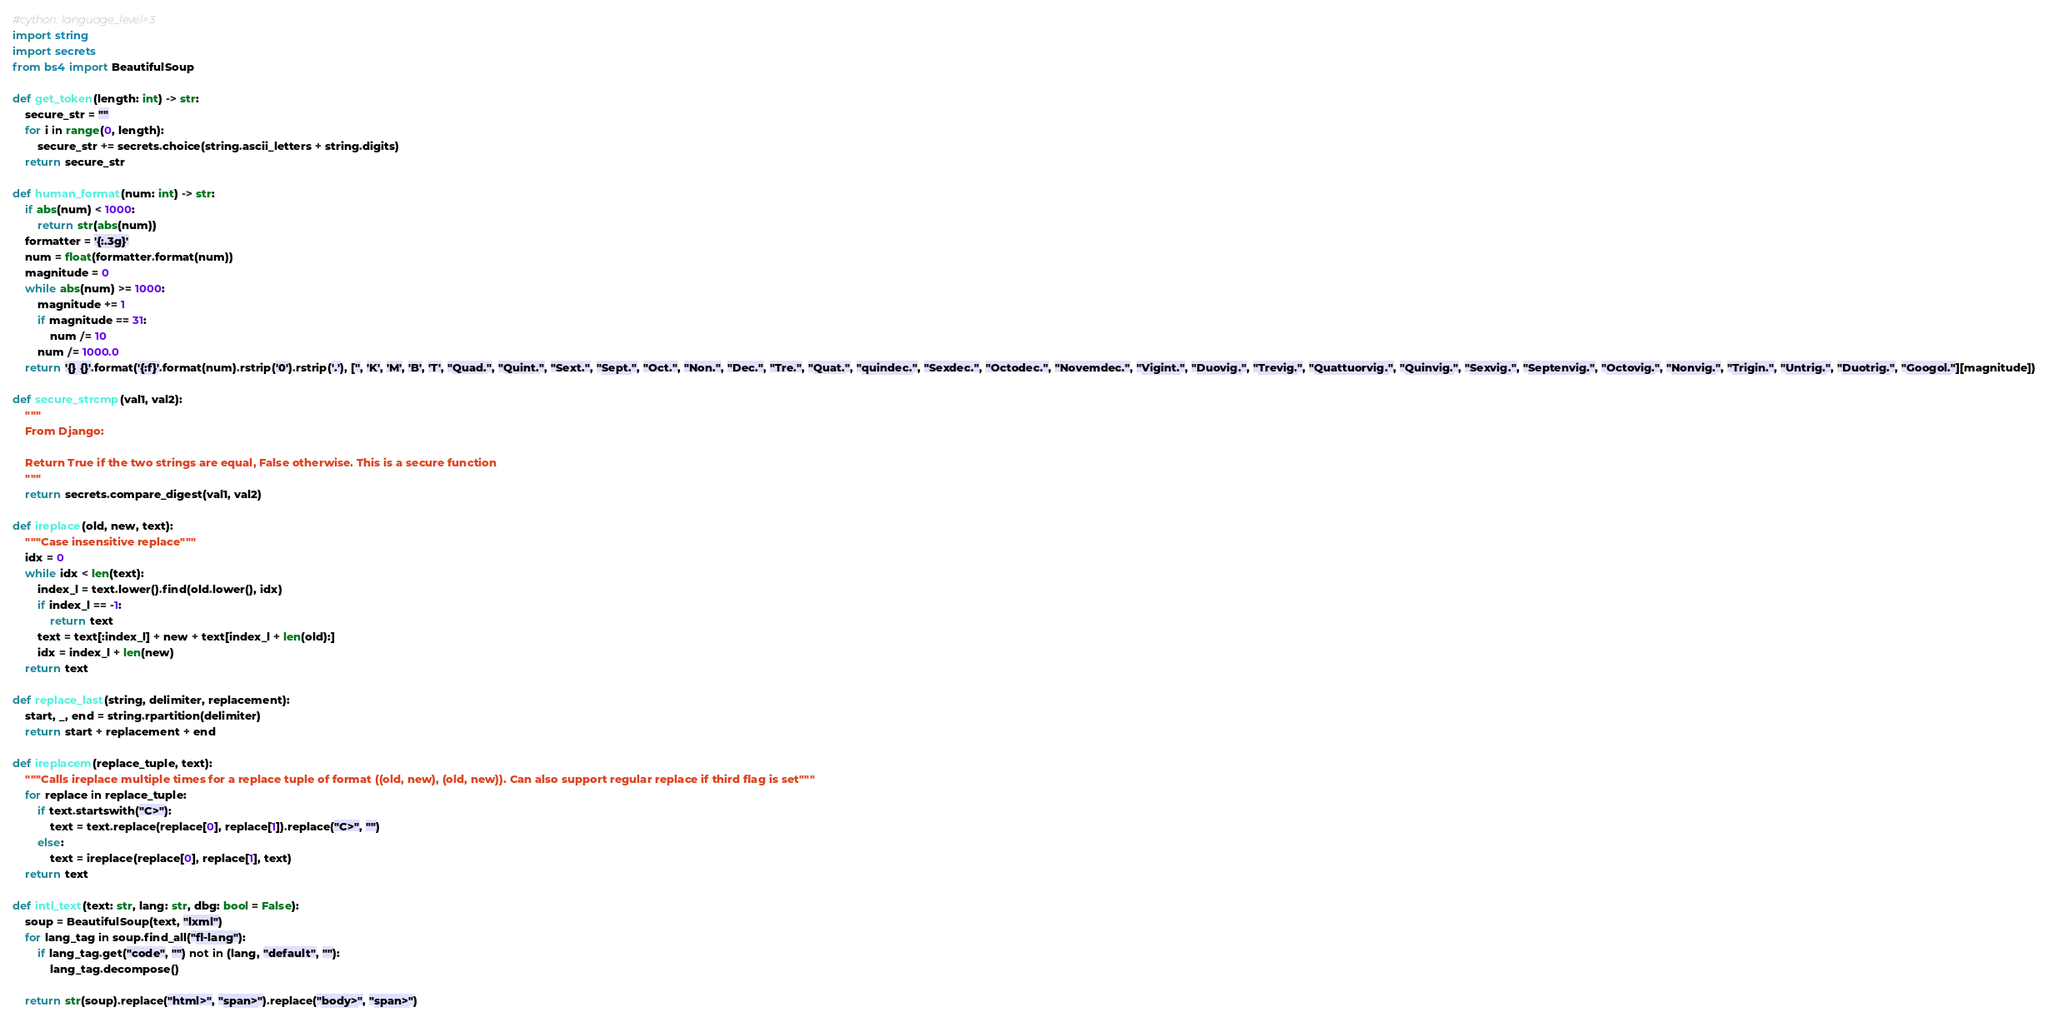Convert code to text. <code><loc_0><loc_0><loc_500><loc_500><_Cython_>#cython: language_level=3
import string
import secrets
from bs4 import BeautifulSoup

def get_token(length: int) -> str:
    secure_str = ""
    for i in range(0, length):
        secure_str += secrets.choice(string.ascii_letters + string.digits)
    return secure_str

def human_format(num: int) -> str:
    if abs(num) < 1000:
        return str(abs(num))
    formatter = '{:.3g}'
    num = float(formatter.format(num))
    magnitude = 0
    while abs(num) >= 1000:
        magnitude += 1
        if magnitude == 31:
            num /= 10
        num /= 1000.0
    return '{} {}'.format('{:f}'.format(num).rstrip('0').rstrip('.'), ['', 'K', 'M', 'B', 'T', "Quad.", "Quint.", "Sext.", "Sept.", "Oct.", "Non.", "Dec.", "Tre.", "Quat.", "quindec.", "Sexdec.", "Octodec.", "Novemdec.", "Vigint.", "Duovig.", "Trevig.", "Quattuorvig.", "Quinvig.", "Sexvig.", "Septenvig.", "Octovig.", "Nonvig.", "Trigin.", "Untrig.", "Duotrig.", "Googol."][magnitude])

def secure_strcmp(val1, val2):
    """
    From Django:
    
    Return True if the two strings are equal, False otherwise. This is a secure function
    """
    return secrets.compare_digest(val1, val2)

def ireplace(old, new, text):
    """Case insensitive replace"""
    idx = 0
    while idx < len(text):
        index_l = text.lower().find(old.lower(), idx)
        if index_l == -1:
            return text
        text = text[:index_l] + new + text[index_l + len(old):]
        idx = index_l + len(new) 
    return text

def replace_last(string, delimiter, replacement):
    start, _, end = string.rpartition(delimiter)
    return start + replacement + end

def ireplacem(replace_tuple, text):
    """Calls ireplace multiple times for a replace tuple of format ((old, new), (old, new)). Can also support regular replace if third flag is set"""
    for replace in replace_tuple:
        if text.startswith("C>"):
            text = text.replace(replace[0], replace[1]).replace("C>", "")
        else:
            text = ireplace(replace[0], replace[1], text)
    return text

def intl_text(text: str, lang: str, dbg: bool = False):
    soup = BeautifulSoup(text, "lxml")
    for lang_tag in soup.find_all("fl-lang"):
        if lang_tag.get("code", "") not in (lang, "default", ""):
            lang_tag.decompose()
    
    return str(soup).replace("html>", "span>").replace("body>", "span>")

</code> 